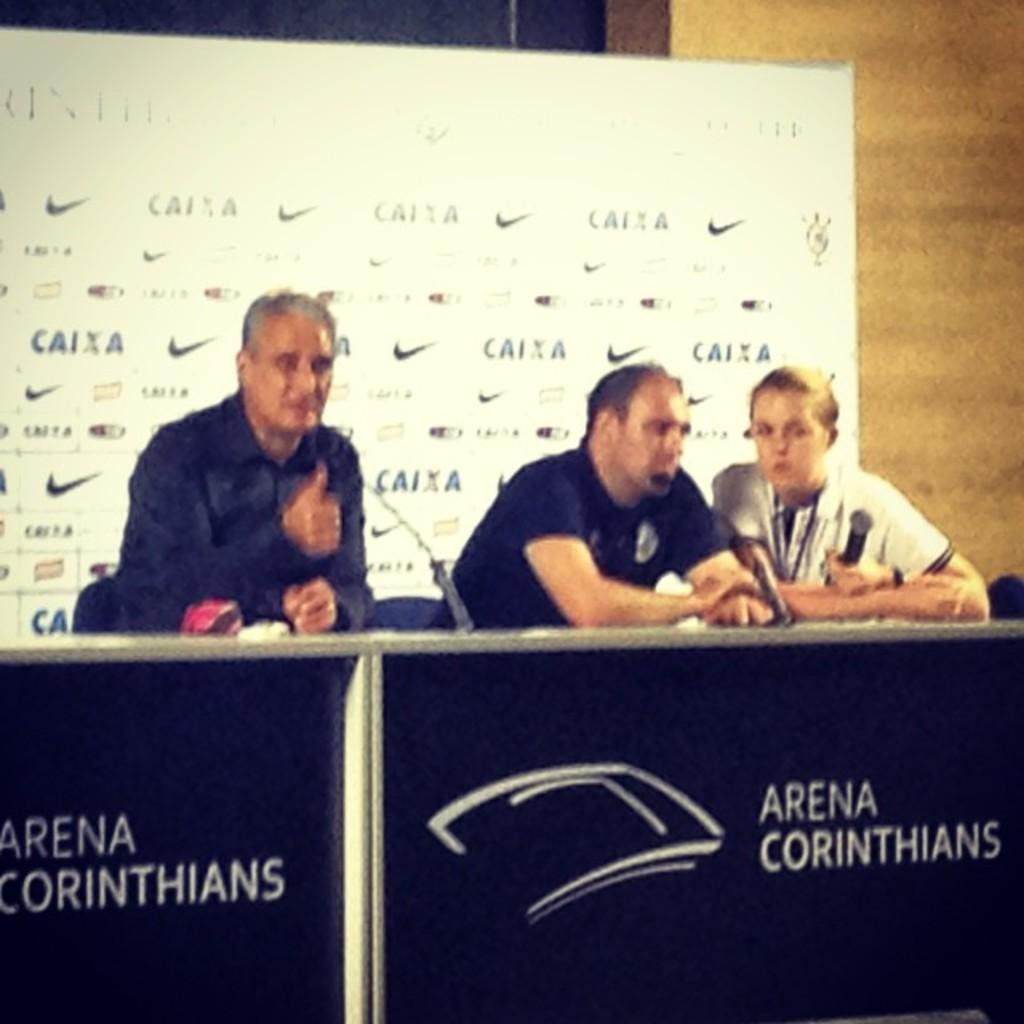What event is taking place in the image? The image is taken during a conference. What can be seen in the center of the image? There are tables, microphones, and people in the center of the image. What is visible in the background of the image? There is a banner, a wall, and a curtain in the background of the image. Where is the library located in the image? There is no library present in the image. What type of game is being played in the center of the image? There is no game being played in the image; it is a conference with tables, microphones, and people. 